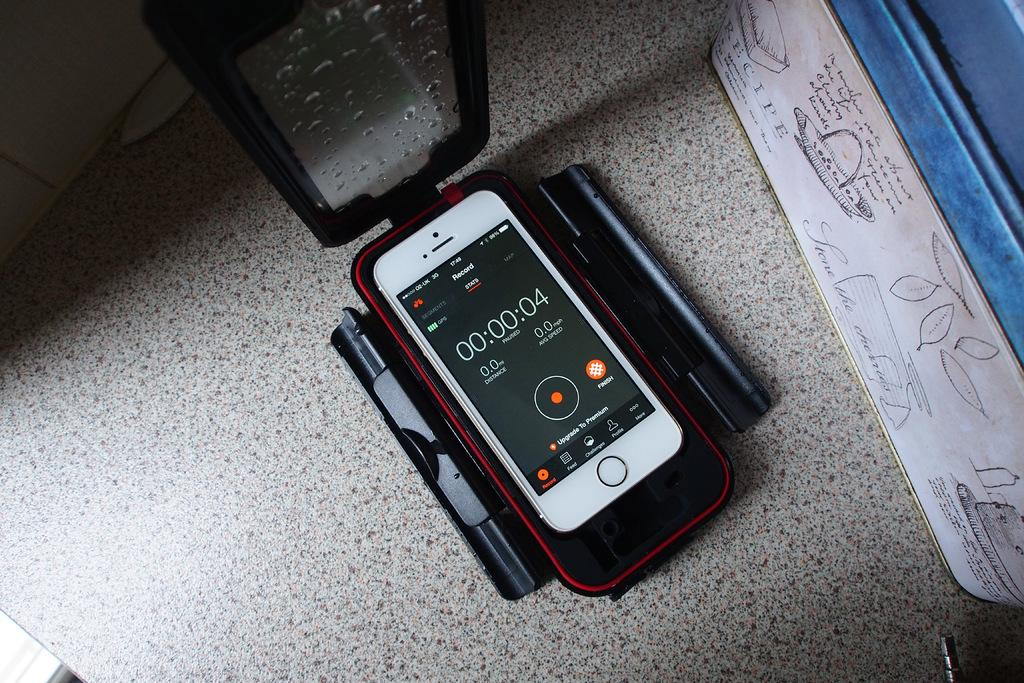Provide a one-sentence caption for the provided image. A cellphone sits in a case of some kind with the Record function displayed. 